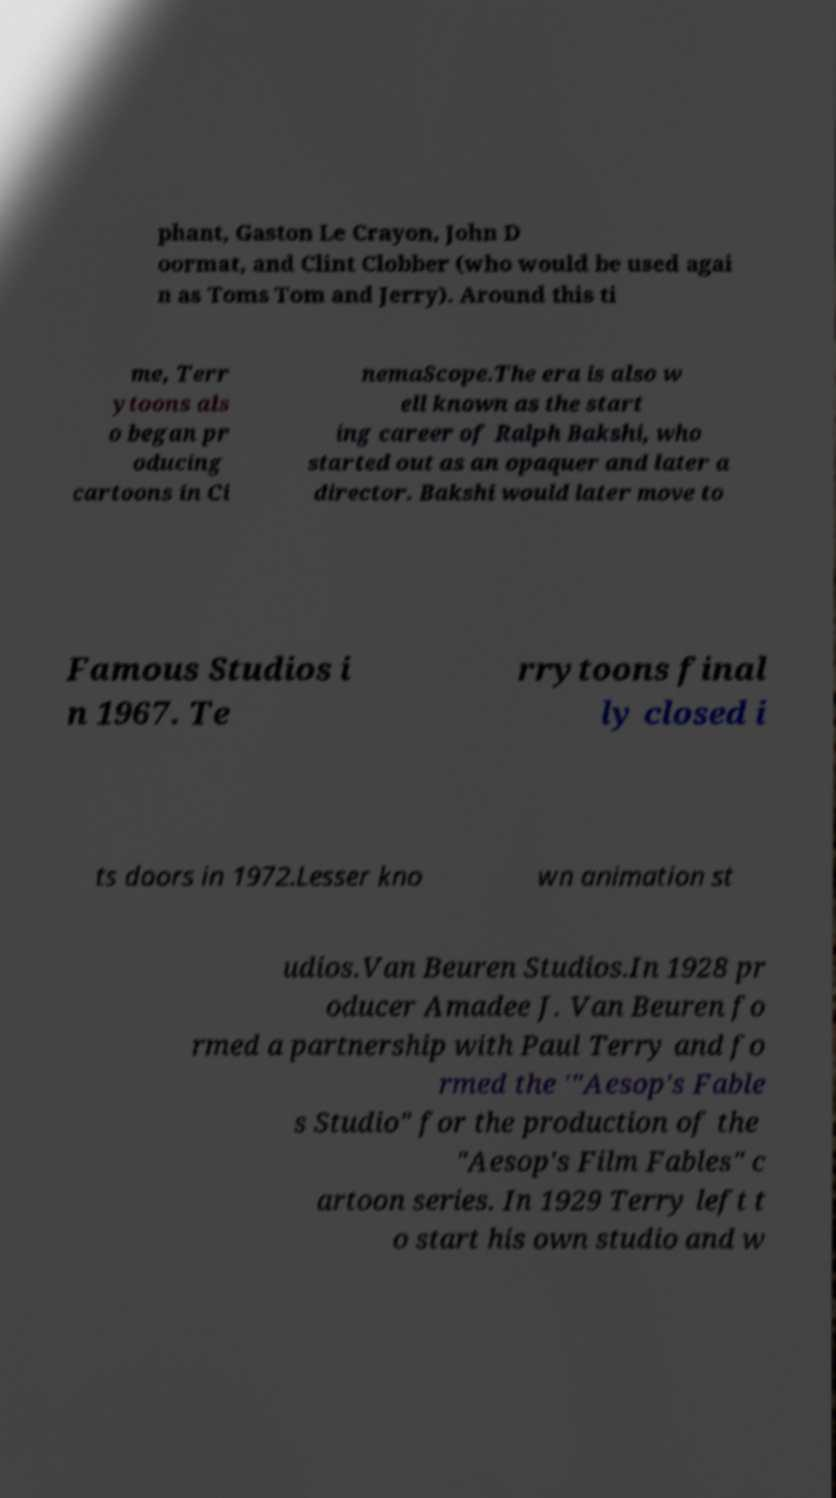There's text embedded in this image that I need extracted. Can you transcribe it verbatim? phant, Gaston Le Crayon, John D oormat, and Clint Clobber (who would be used agai n as Toms Tom and Jerry). Around this ti me, Terr ytoons als o began pr oducing cartoons in Ci nemaScope.The era is also w ell known as the start ing career of Ralph Bakshi, who started out as an opaquer and later a director. Bakshi would later move to Famous Studios i n 1967. Te rrytoons final ly closed i ts doors in 1972.Lesser kno wn animation st udios.Van Beuren Studios.In 1928 pr oducer Amadee J. Van Beuren fo rmed a partnership with Paul Terry and fo rmed the '"Aesop's Fable s Studio" for the production of the "Aesop's Film Fables" c artoon series. In 1929 Terry left t o start his own studio and w 